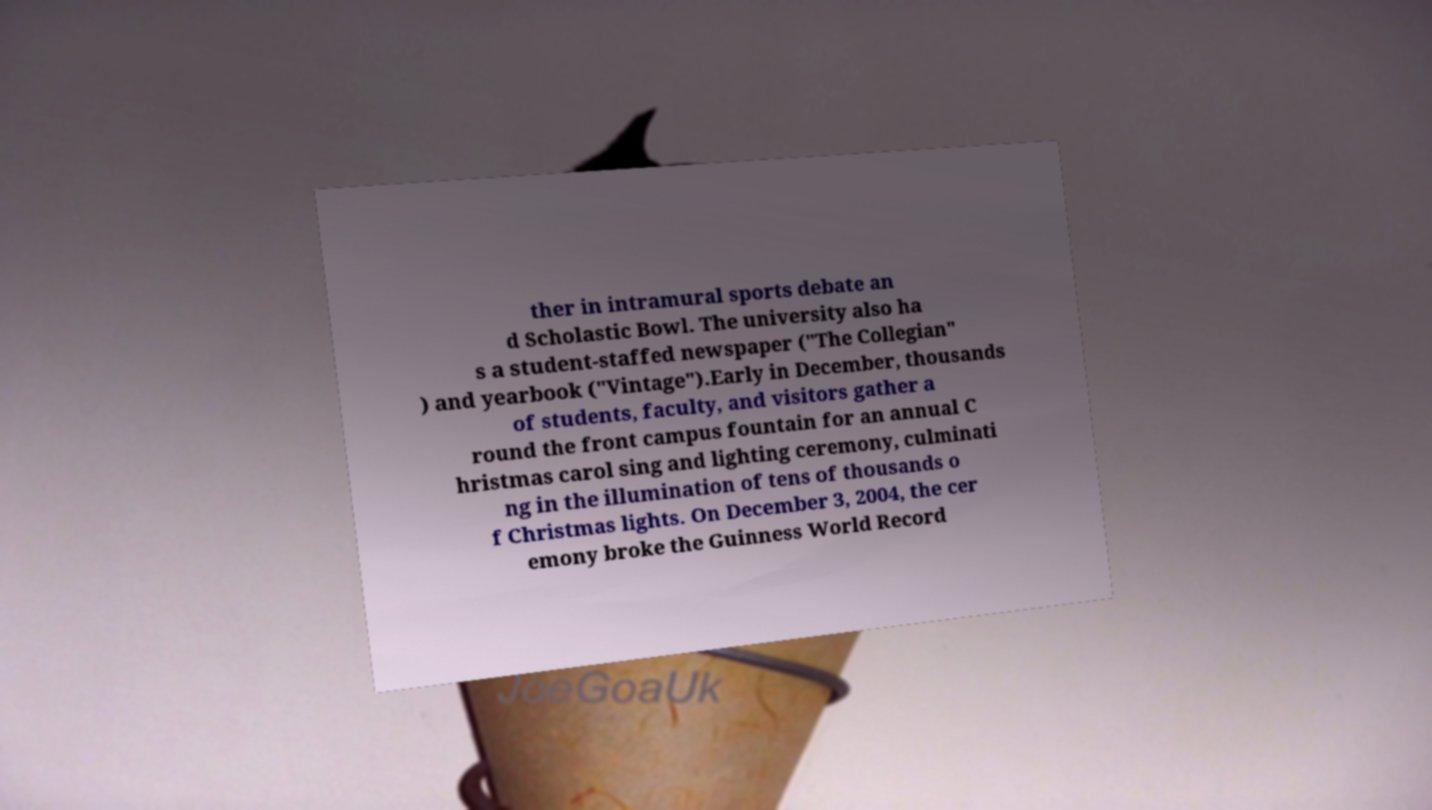Could you extract and type out the text from this image? ther in intramural sports debate an d Scholastic Bowl. The university also ha s a student-staffed newspaper ("The Collegian" ) and yearbook ("Vintage").Early in December, thousands of students, faculty, and visitors gather a round the front campus fountain for an annual C hristmas carol sing and lighting ceremony, culminati ng in the illumination of tens of thousands o f Christmas lights. On December 3, 2004, the cer emony broke the Guinness World Record 